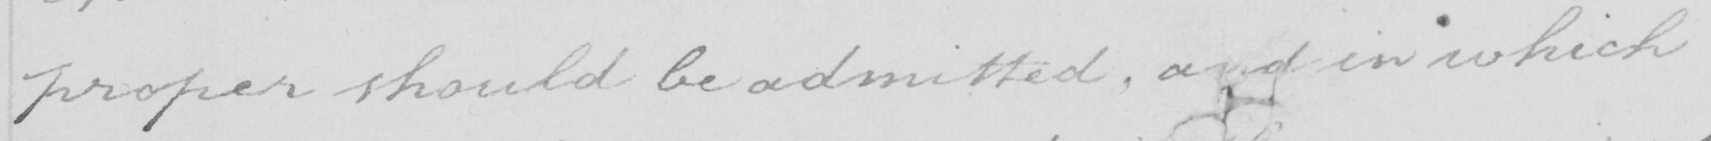What text is written in this handwritten line? proper should be admitted , and in which 